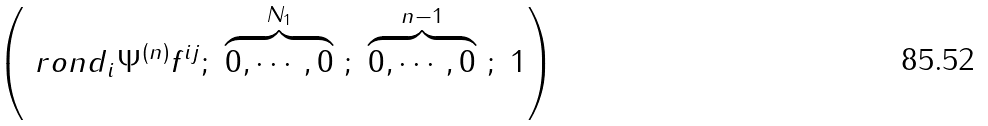<formula> <loc_0><loc_0><loc_500><loc_500>\left ( \ r o n d _ { i } \Psi ^ { ( n ) } f ^ { i j } ; \ \overbrace { 0 , \cdots , 0 } ^ { N _ { 1 } } \ ; \ \overbrace { 0 , \cdots , 0 } ^ { n - 1 } \ ; \ 1 \right )</formula> 